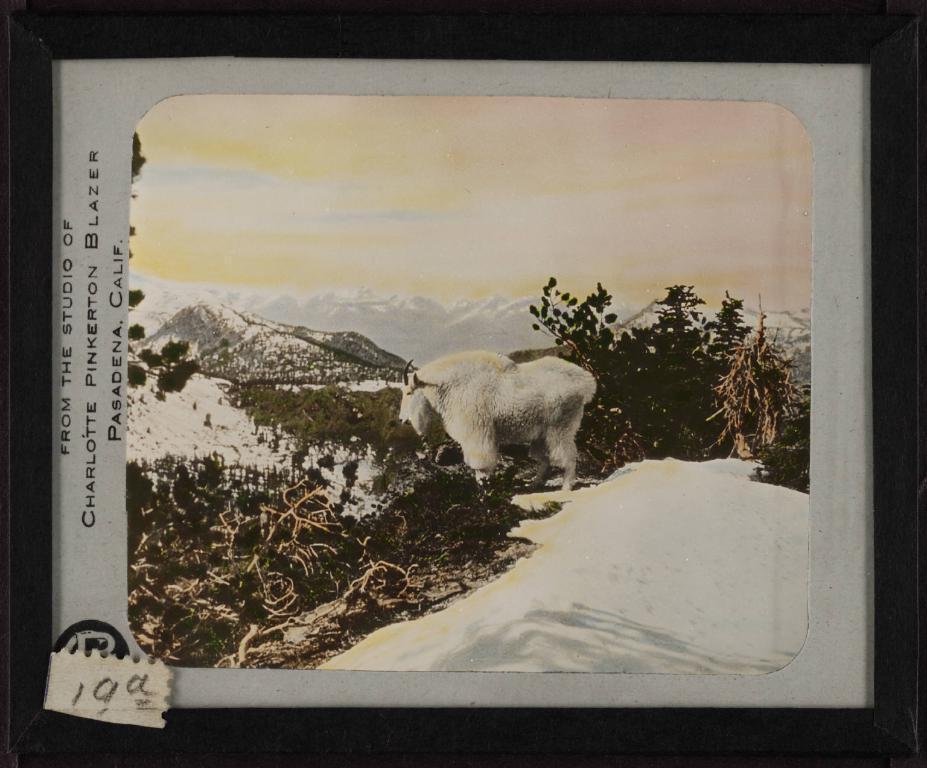In one or two sentences, can you explain what this image depicts? In the center of the picture there is an antelope. In the foreground there are plants and snow. In the background there are mountains covered with snow and there are trees. On the left there is text. The picture has black border. 